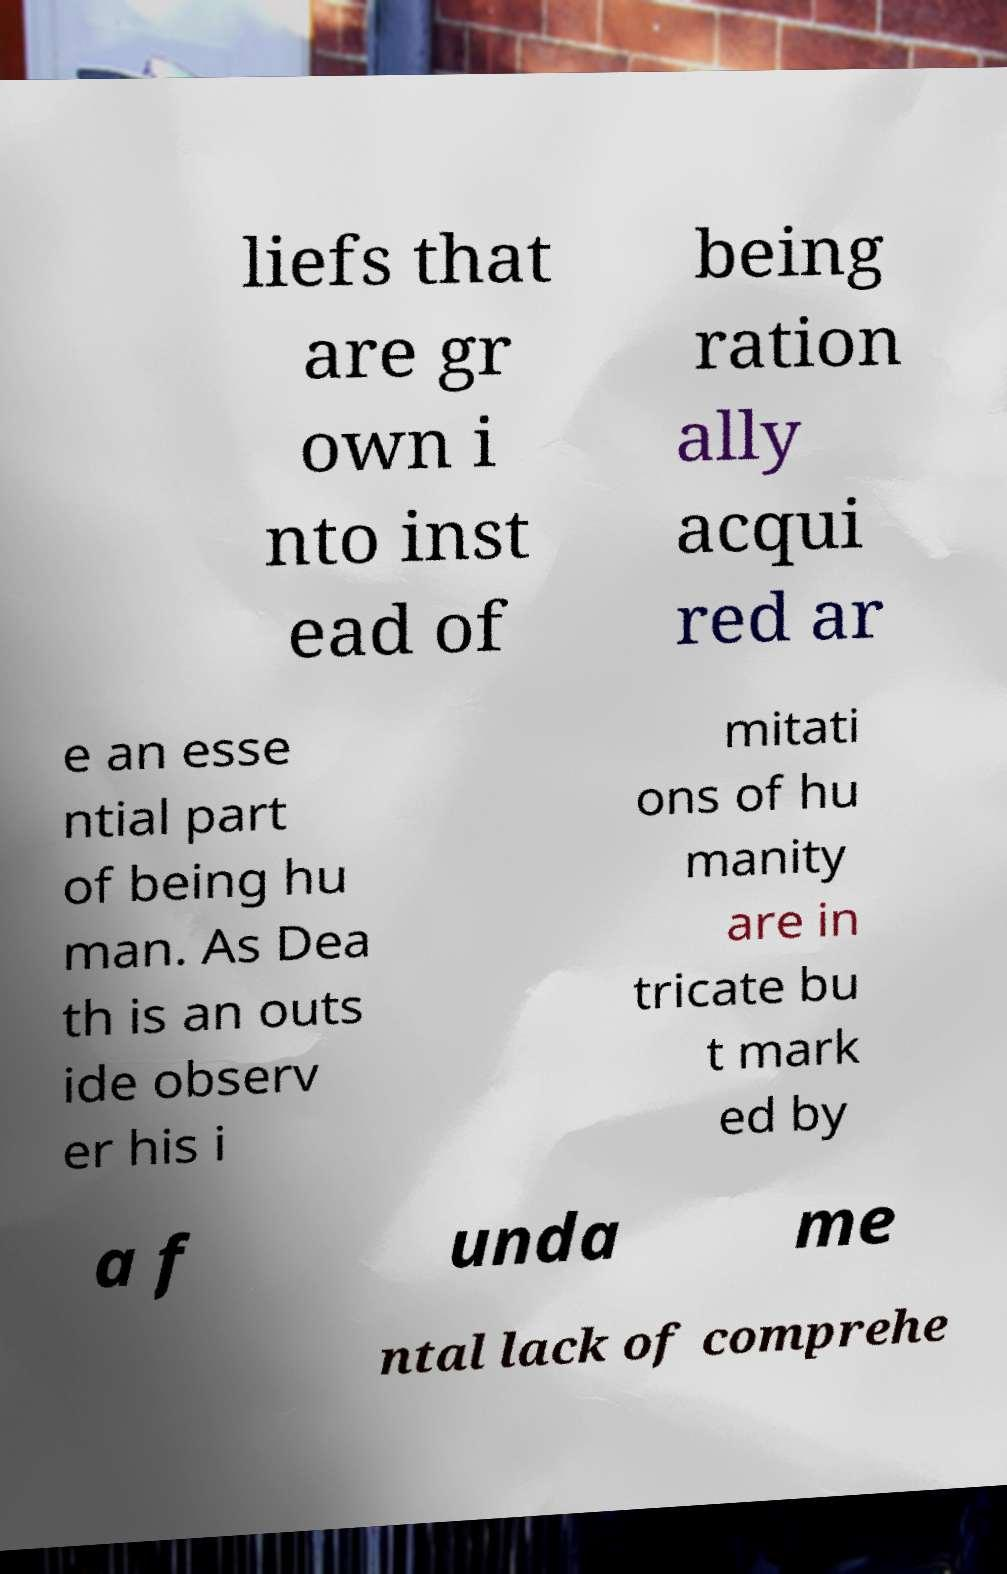Could you extract and type out the text from this image? liefs that are gr own i nto inst ead of being ration ally acqui red ar e an esse ntial part of being hu man. As Dea th is an outs ide observ er his i mitati ons of hu manity are in tricate bu t mark ed by a f unda me ntal lack of comprehe 